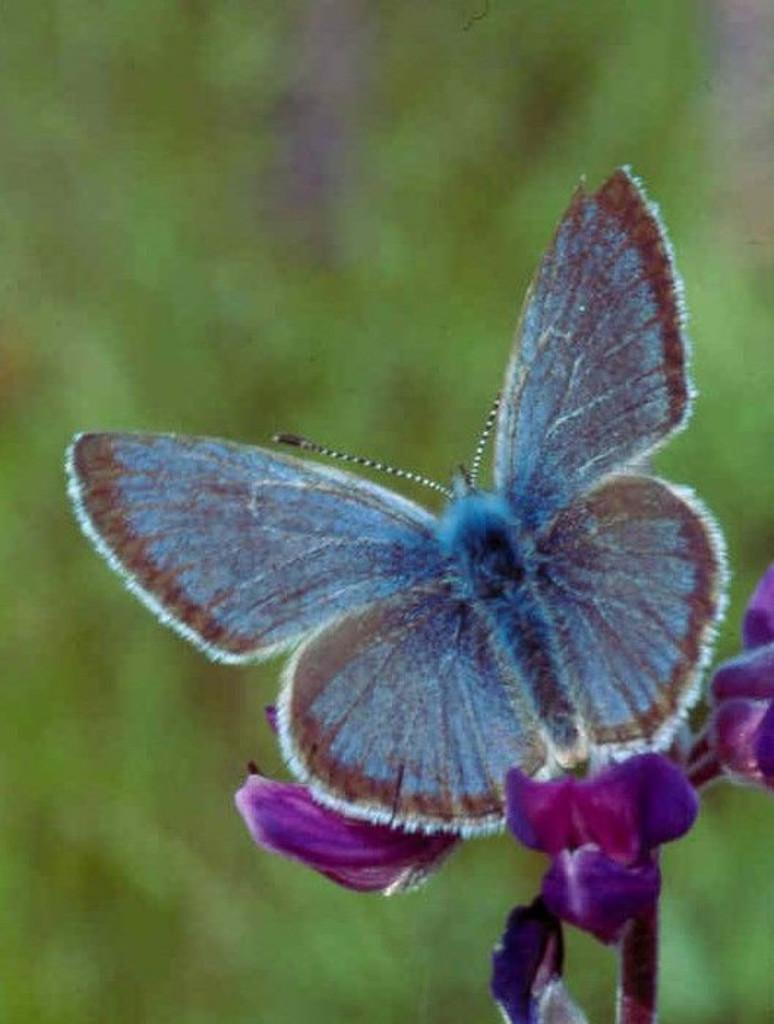What is on the flower in the image? There is a butterfly on the flower in the image. What color is the flower? The flower is violet in color. What can be seen in the background of the image? There are plants visible in the background, but they are not clearly visible. What is the taste of the quarter in the image? There is no quarter present in the image, so it cannot be tasted. 